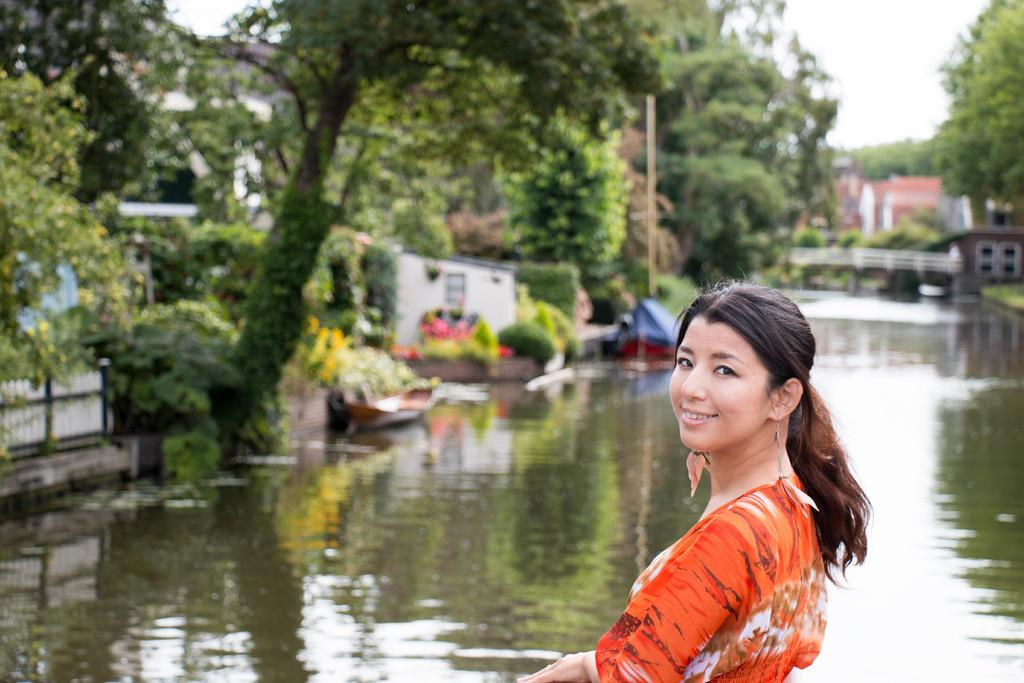What is the person in the image wearing? The person in the image is wearing an orange and white color dress. What can be seen in the background of the image? There are trees, buildings, and water visible in the image. Can you describe the overall quality of the image? The image is blurred. What is the person's annual income based on the image? There is no information about the person's income in the image. Can you see a spade being used in the image? There is no spade present in the image. 